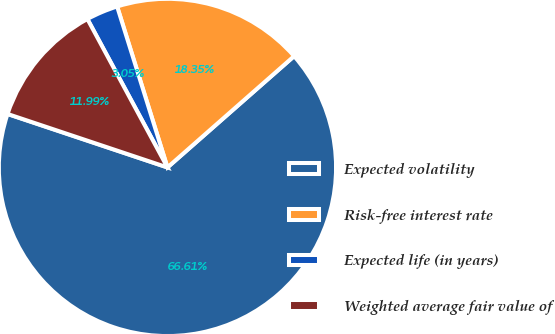Convert chart. <chart><loc_0><loc_0><loc_500><loc_500><pie_chart><fcel>Expected volatility<fcel>Risk-free interest rate<fcel>Expected life (in years)<fcel>Weighted average fair value of<nl><fcel>66.61%<fcel>18.35%<fcel>3.05%<fcel>11.99%<nl></chart> 